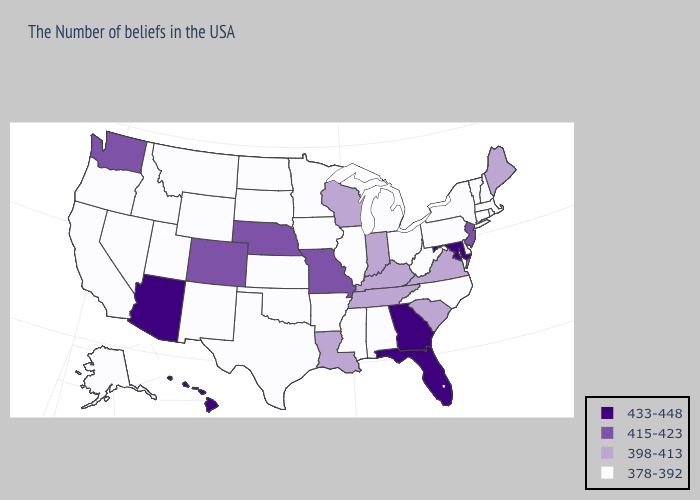Does the map have missing data?
Give a very brief answer. No. What is the lowest value in the USA?
Quick response, please. 378-392. Name the states that have a value in the range 415-423?
Concise answer only. New Jersey, Missouri, Nebraska, Colorado, Washington. Does North Dakota have the same value as Colorado?
Keep it brief. No. Which states hav the highest value in the West?
Give a very brief answer. Arizona, Hawaii. Does Mississippi have a higher value than Vermont?
Quick response, please. No. What is the lowest value in the MidWest?
Concise answer only. 378-392. Which states hav the highest value in the South?
Keep it brief. Maryland, Florida, Georgia. Does Arizona have the highest value in the USA?
Keep it brief. Yes. Name the states that have a value in the range 398-413?
Be succinct. Maine, Virginia, South Carolina, Kentucky, Indiana, Tennessee, Wisconsin, Louisiana. Does Massachusetts have the lowest value in the Northeast?
Keep it brief. Yes. What is the value of North Carolina?
Keep it brief. 378-392. Name the states that have a value in the range 433-448?
Answer briefly. Maryland, Florida, Georgia, Arizona, Hawaii. Does Montana have the lowest value in the USA?
Short answer required. Yes. 